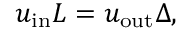Convert formula to latex. <formula><loc_0><loc_0><loc_500><loc_500>u _ { i n } L = u _ { o u t } \Delta ,</formula> 